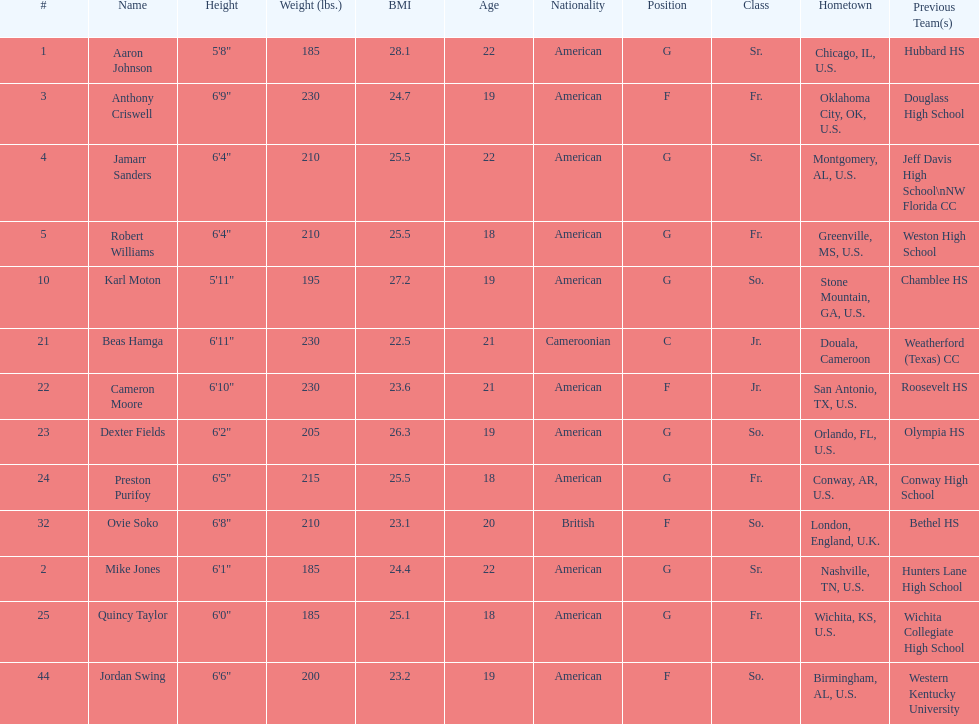Who has a higher weight, dexter fields or ovie soko? Ovie Soko. 